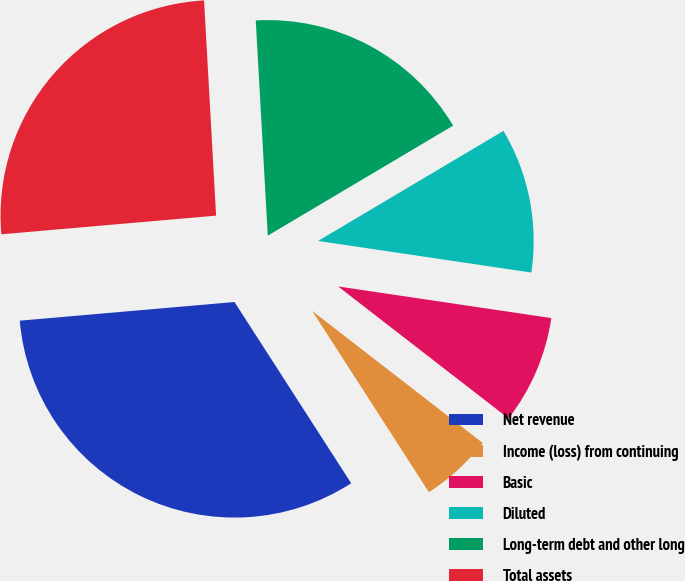Convert chart. <chart><loc_0><loc_0><loc_500><loc_500><pie_chart><fcel>Net revenue<fcel>Income (loss) from continuing<fcel>Basic<fcel>Diluted<fcel>Long-term debt and other long<fcel>Total assets<nl><fcel>32.72%<fcel>5.41%<fcel>8.14%<fcel>10.87%<fcel>17.36%<fcel>25.49%<nl></chart> 